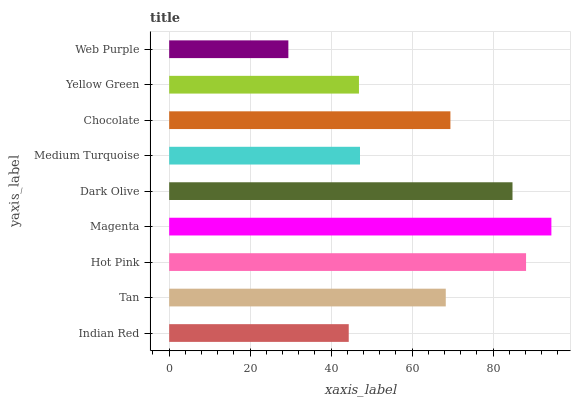Is Web Purple the minimum?
Answer yes or no. Yes. Is Magenta the maximum?
Answer yes or no. Yes. Is Tan the minimum?
Answer yes or no. No. Is Tan the maximum?
Answer yes or no. No. Is Tan greater than Indian Red?
Answer yes or no. Yes. Is Indian Red less than Tan?
Answer yes or no. Yes. Is Indian Red greater than Tan?
Answer yes or no. No. Is Tan less than Indian Red?
Answer yes or no. No. Is Tan the high median?
Answer yes or no. Yes. Is Tan the low median?
Answer yes or no. Yes. Is Chocolate the high median?
Answer yes or no. No. Is Indian Red the low median?
Answer yes or no. No. 